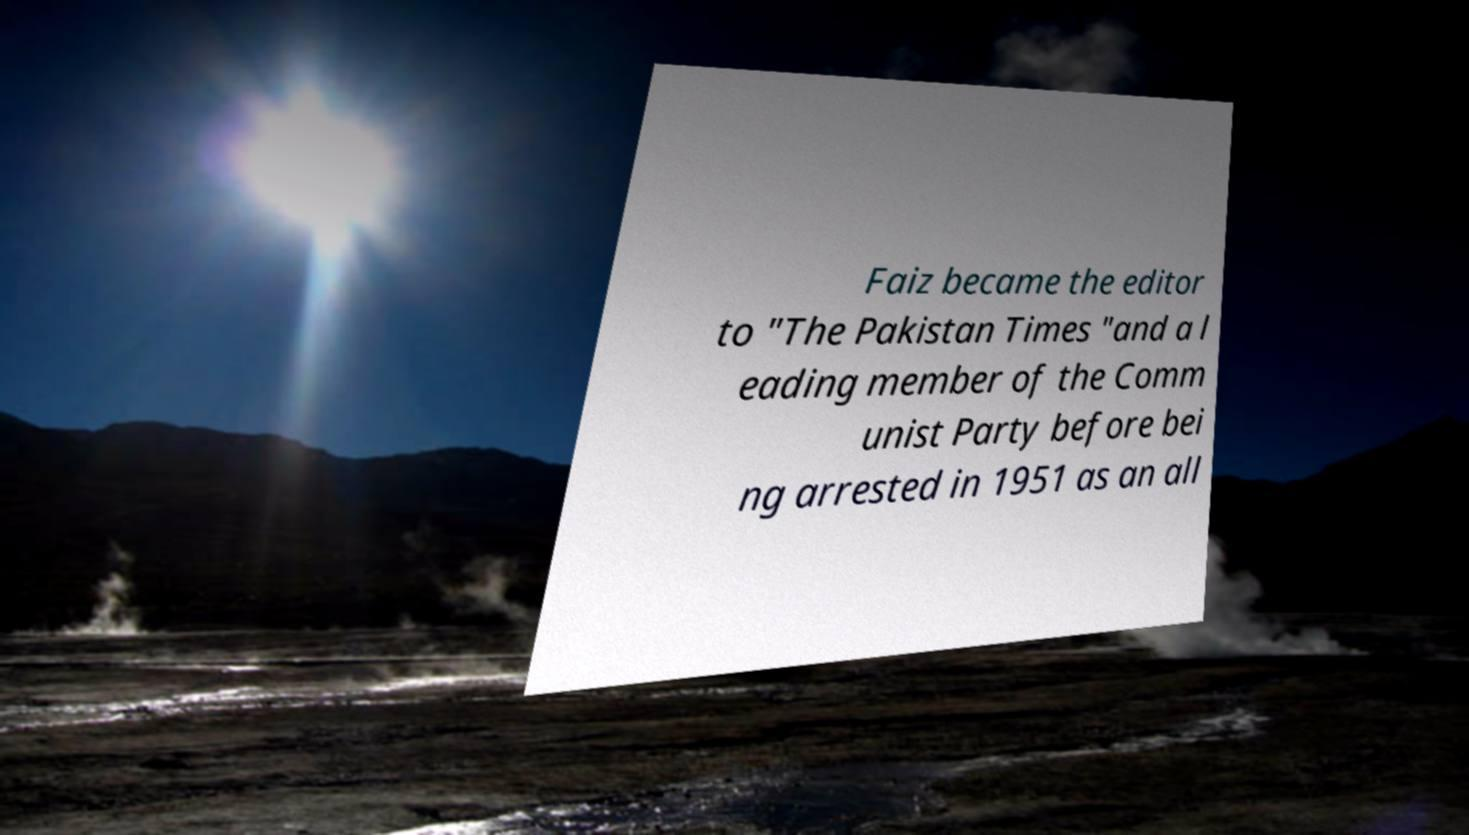Can you accurately transcribe the text from the provided image for me? Faiz became the editor to "The Pakistan Times "and a l eading member of the Comm unist Party before bei ng arrested in 1951 as an all 